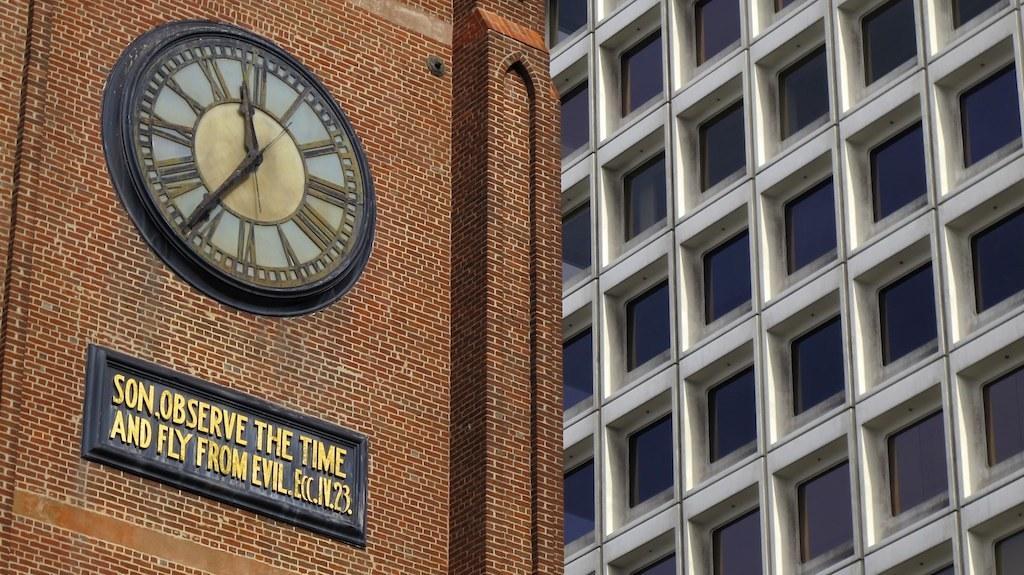In one or two sentences, can you explain what this image depicts? On the right side of this image there is a building along with the window glasses. On the left side there is a clock tower. At the bottom there is a board on which I can see some text. 